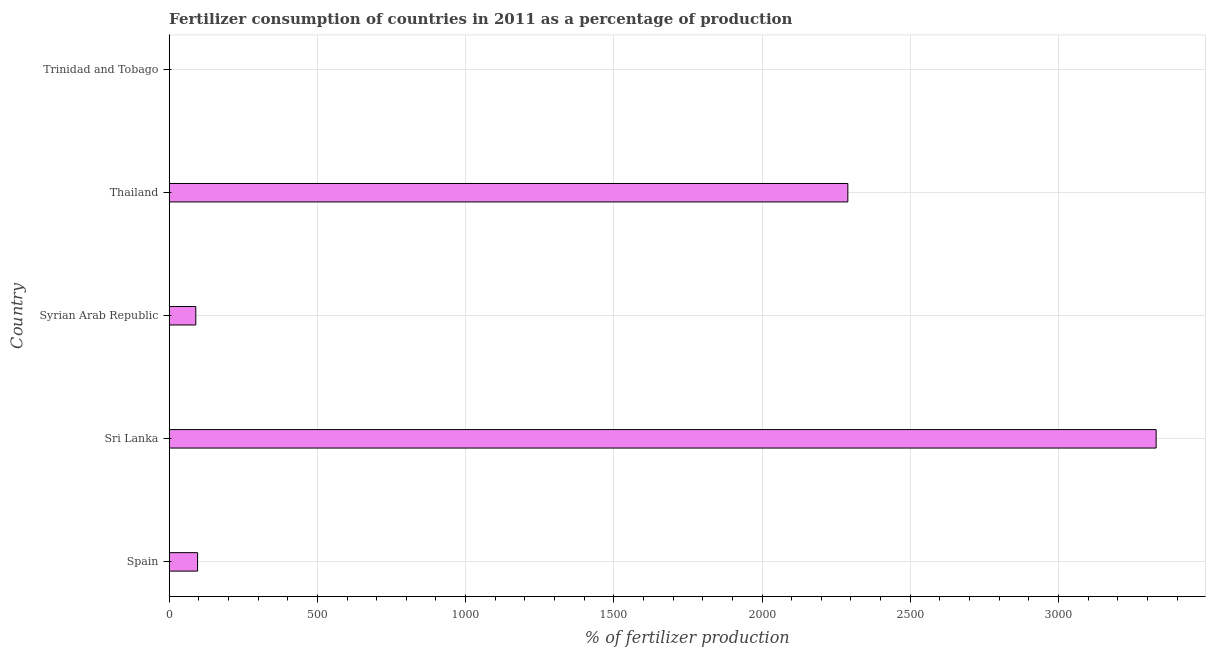Does the graph contain grids?
Give a very brief answer. Yes. What is the title of the graph?
Provide a succinct answer. Fertilizer consumption of countries in 2011 as a percentage of production. What is the label or title of the X-axis?
Ensure brevity in your answer.  % of fertilizer production. What is the amount of fertilizer consumption in Syrian Arab Republic?
Your response must be concise. 89.76. Across all countries, what is the maximum amount of fertilizer consumption?
Your answer should be compact. 3329.6. Across all countries, what is the minimum amount of fertilizer consumption?
Offer a very short reply. 0.76. In which country was the amount of fertilizer consumption maximum?
Provide a succinct answer. Sri Lanka. In which country was the amount of fertilizer consumption minimum?
Ensure brevity in your answer.  Trinidad and Tobago. What is the sum of the amount of fertilizer consumption?
Ensure brevity in your answer.  5805.34. What is the difference between the amount of fertilizer consumption in Sri Lanka and Thailand?
Offer a very short reply. 1040.11. What is the average amount of fertilizer consumption per country?
Your response must be concise. 1161.07. What is the median amount of fertilizer consumption?
Make the answer very short. 95.72. In how many countries, is the amount of fertilizer consumption greater than 2400 %?
Make the answer very short. 1. What is the ratio of the amount of fertilizer consumption in Spain to that in Syrian Arab Republic?
Provide a succinct answer. 1.07. Is the amount of fertilizer consumption in Syrian Arab Republic less than that in Trinidad and Tobago?
Provide a succinct answer. No. Is the difference between the amount of fertilizer consumption in Sri Lanka and Thailand greater than the difference between any two countries?
Your answer should be compact. No. What is the difference between the highest and the second highest amount of fertilizer consumption?
Offer a very short reply. 1040.11. Is the sum of the amount of fertilizer consumption in Sri Lanka and Trinidad and Tobago greater than the maximum amount of fertilizer consumption across all countries?
Your answer should be very brief. Yes. What is the difference between the highest and the lowest amount of fertilizer consumption?
Your answer should be compact. 3328.84. How many bars are there?
Offer a very short reply. 5. How many countries are there in the graph?
Your answer should be compact. 5. What is the difference between two consecutive major ticks on the X-axis?
Make the answer very short. 500. Are the values on the major ticks of X-axis written in scientific E-notation?
Make the answer very short. No. What is the % of fertilizer production of Spain?
Offer a terse response. 95.72. What is the % of fertilizer production of Sri Lanka?
Make the answer very short. 3329.6. What is the % of fertilizer production in Syrian Arab Republic?
Your response must be concise. 89.76. What is the % of fertilizer production of Thailand?
Make the answer very short. 2289.49. What is the % of fertilizer production in Trinidad and Tobago?
Provide a succinct answer. 0.76. What is the difference between the % of fertilizer production in Spain and Sri Lanka?
Your response must be concise. -3233.88. What is the difference between the % of fertilizer production in Spain and Syrian Arab Republic?
Your answer should be very brief. 5.97. What is the difference between the % of fertilizer production in Spain and Thailand?
Keep it short and to the point. -2193.77. What is the difference between the % of fertilizer production in Spain and Trinidad and Tobago?
Provide a short and direct response. 94.96. What is the difference between the % of fertilizer production in Sri Lanka and Syrian Arab Republic?
Provide a short and direct response. 3239.84. What is the difference between the % of fertilizer production in Sri Lanka and Thailand?
Offer a very short reply. 1040.11. What is the difference between the % of fertilizer production in Sri Lanka and Trinidad and Tobago?
Your response must be concise. 3328.84. What is the difference between the % of fertilizer production in Syrian Arab Republic and Thailand?
Offer a terse response. -2199.74. What is the difference between the % of fertilizer production in Syrian Arab Republic and Trinidad and Tobago?
Offer a very short reply. 89. What is the difference between the % of fertilizer production in Thailand and Trinidad and Tobago?
Make the answer very short. 2288.73. What is the ratio of the % of fertilizer production in Spain to that in Sri Lanka?
Provide a succinct answer. 0.03. What is the ratio of the % of fertilizer production in Spain to that in Syrian Arab Republic?
Offer a very short reply. 1.07. What is the ratio of the % of fertilizer production in Spain to that in Thailand?
Ensure brevity in your answer.  0.04. What is the ratio of the % of fertilizer production in Spain to that in Trinidad and Tobago?
Keep it short and to the point. 125.76. What is the ratio of the % of fertilizer production in Sri Lanka to that in Syrian Arab Republic?
Offer a very short reply. 37.09. What is the ratio of the % of fertilizer production in Sri Lanka to that in Thailand?
Keep it short and to the point. 1.45. What is the ratio of the % of fertilizer production in Sri Lanka to that in Trinidad and Tobago?
Offer a very short reply. 4374.24. What is the ratio of the % of fertilizer production in Syrian Arab Republic to that in Thailand?
Your answer should be compact. 0.04. What is the ratio of the % of fertilizer production in Syrian Arab Republic to that in Trinidad and Tobago?
Offer a very short reply. 117.92. What is the ratio of the % of fertilizer production in Thailand to that in Trinidad and Tobago?
Make the answer very short. 3007.8. 